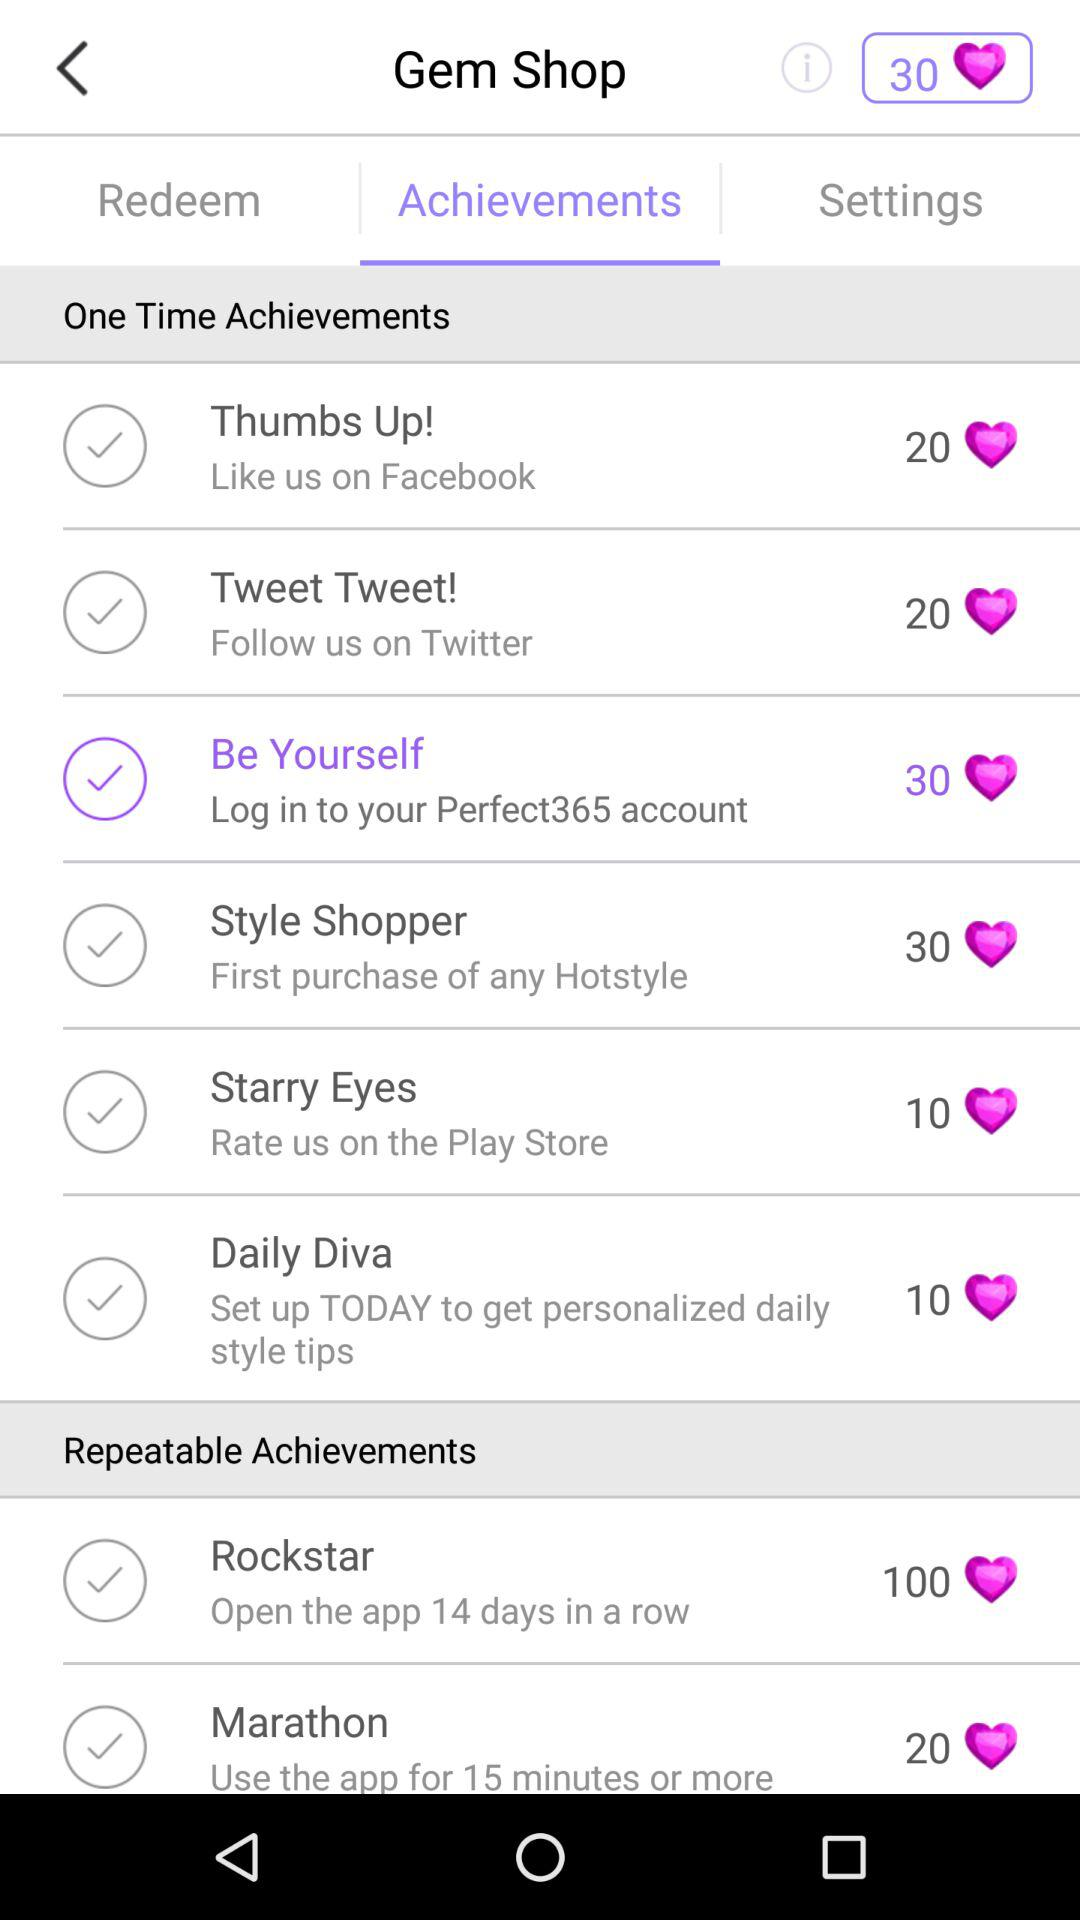Which tab has been selected? The selected tab is "Achievements". 